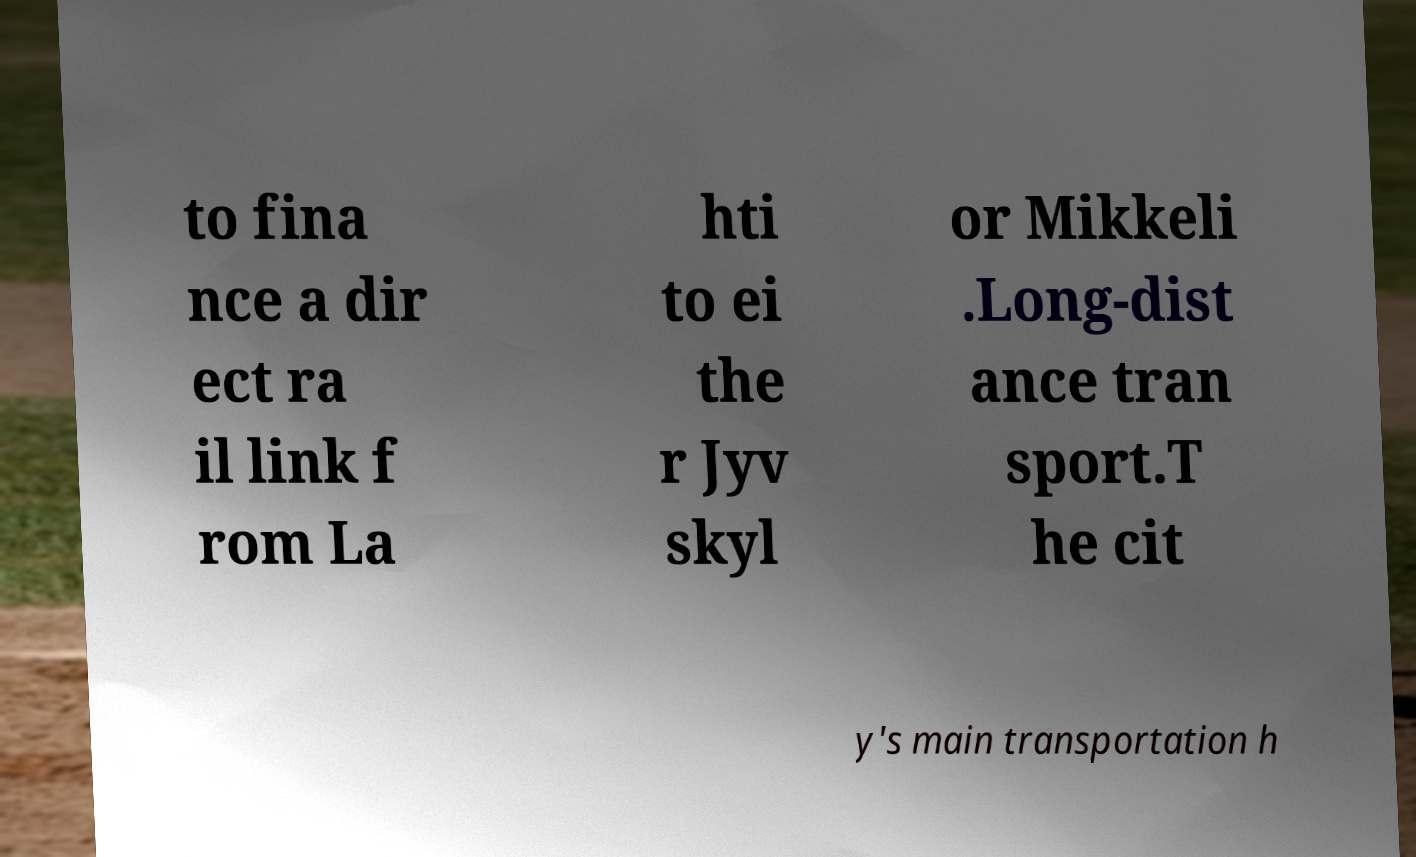Could you extract and type out the text from this image? to fina nce a dir ect ra il link f rom La hti to ei the r Jyv skyl or Mikkeli .Long-dist ance tran sport.T he cit y's main transportation h 